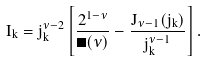<formula> <loc_0><loc_0><loc_500><loc_500>I _ { k } = j _ { k } ^ { \nu - 2 } \left [ \frac { 2 ^ { 1 - \nu } } { \Gamma ( \nu ) } - \frac { J _ { \nu - 1 } ( j _ { k } ) } { j _ { k } ^ { \nu - 1 } } \right ] .</formula> 